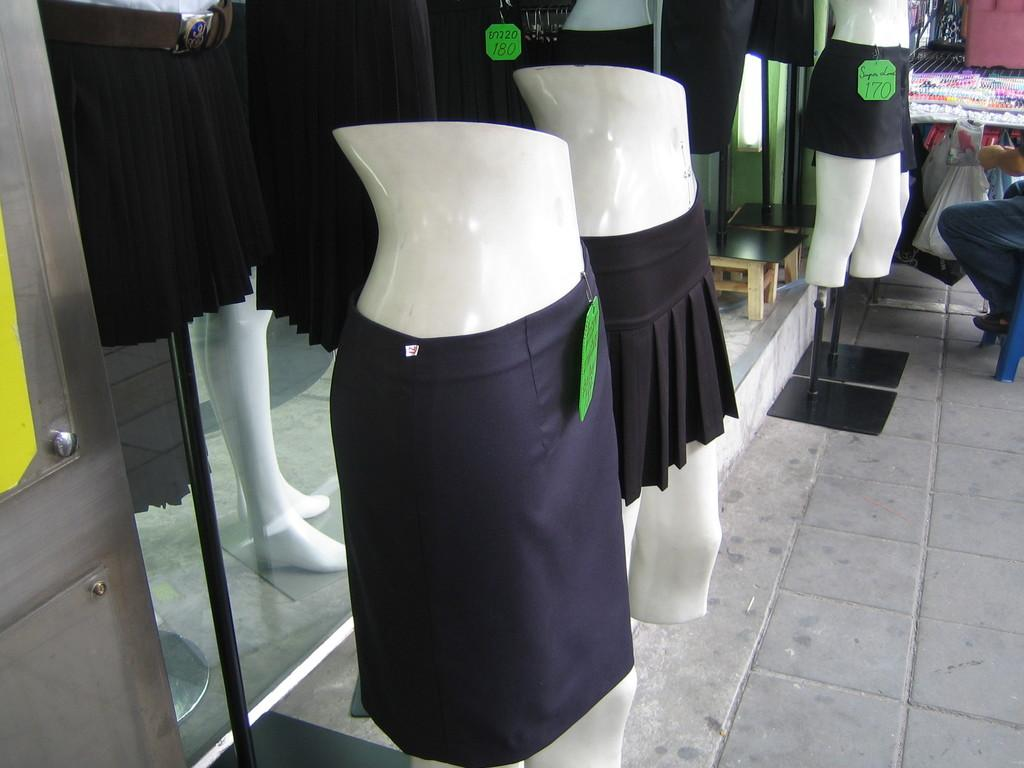What type of figures can be seen in the image? There are mannequins in the image. What are the mannequins wearing? The mannequins are wearing black color skirts. Where are the mannequins located? The mannequins are standing in a shop. What can be seen in the background of the image? There is a glass shop in the background of the image. What type of advice does the mannequin's dad give them in the image? There is no mention of a dad or any advice-giving in the image; it features mannequins wearing black color skirts in a shop. 